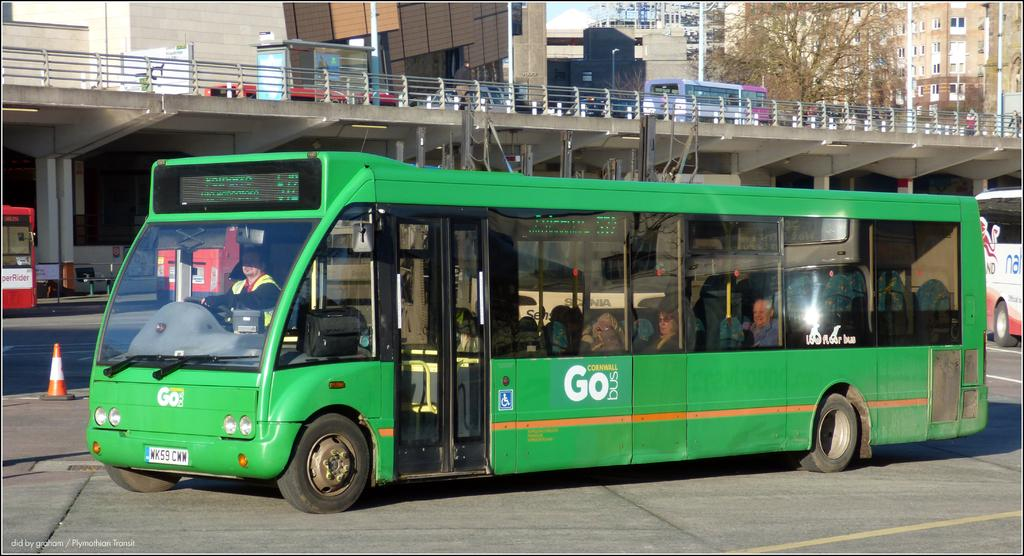<image>
Give a short and clear explanation of the subsequent image. The green bus on the street has the company name Go Bus on it 